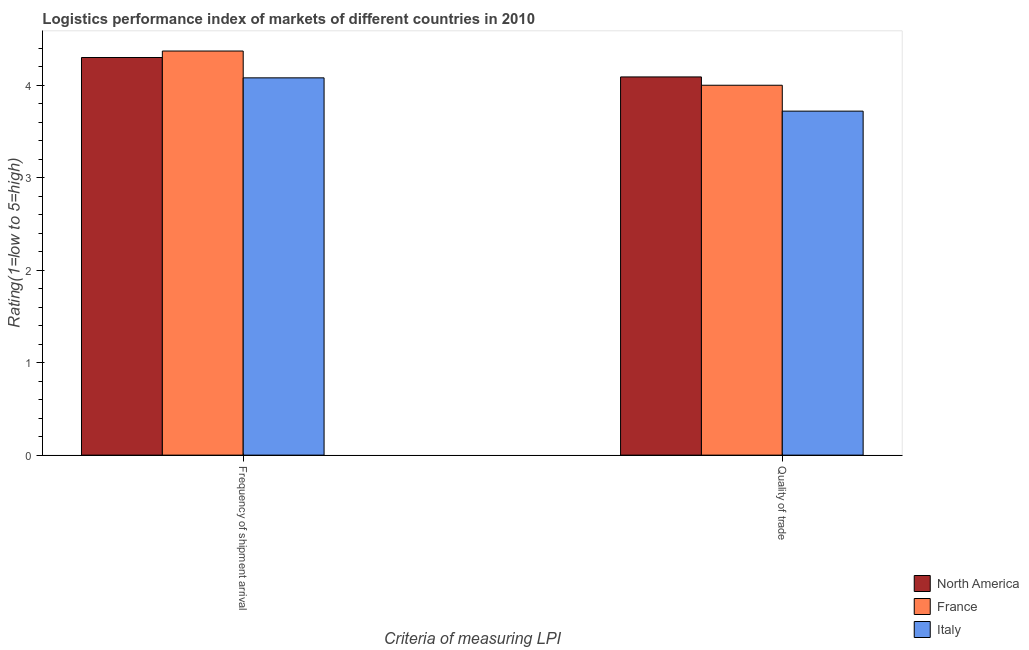How many groups of bars are there?
Provide a succinct answer. 2. Are the number of bars per tick equal to the number of legend labels?
Your response must be concise. Yes. Are the number of bars on each tick of the X-axis equal?
Provide a short and direct response. Yes. How many bars are there on the 1st tick from the right?
Provide a short and direct response. 3. What is the label of the 2nd group of bars from the left?
Your response must be concise. Quality of trade. What is the lpi quality of trade in North America?
Make the answer very short. 4.09. Across all countries, what is the maximum lpi of frequency of shipment arrival?
Your answer should be very brief. 4.37. Across all countries, what is the minimum lpi quality of trade?
Your response must be concise. 3.72. What is the total lpi of frequency of shipment arrival in the graph?
Ensure brevity in your answer.  12.75. What is the difference between the lpi of frequency of shipment arrival in North America and that in Italy?
Ensure brevity in your answer.  0.22. What is the difference between the lpi quality of trade in France and the lpi of frequency of shipment arrival in North America?
Your answer should be very brief. -0.3. What is the average lpi quality of trade per country?
Give a very brief answer. 3.94. What is the difference between the lpi quality of trade and lpi of frequency of shipment arrival in Italy?
Provide a succinct answer. -0.36. In how many countries, is the lpi of frequency of shipment arrival greater than 1.6 ?
Offer a very short reply. 3. What is the ratio of the lpi of frequency of shipment arrival in North America to that in France?
Provide a short and direct response. 0.98. Is the lpi quality of trade in France less than that in Italy?
Offer a very short reply. No. In how many countries, is the lpi of frequency of shipment arrival greater than the average lpi of frequency of shipment arrival taken over all countries?
Ensure brevity in your answer.  2. What does the 3rd bar from the left in Quality of trade represents?
Provide a short and direct response. Italy. What does the 3rd bar from the right in Quality of trade represents?
Keep it short and to the point. North America. How many countries are there in the graph?
Your answer should be compact. 3. Are the values on the major ticks of Y-axis written in scientific E-notation?
Make the answer very short. No. Does the graph contain any zero values?
Provide a succinct answer. No. How are the legend labels stacked?
Ensure brevity in your answer.  Vertical. What is the title of the graph?
Make the answer very short. Logistics performance index of markets of different countries in 2010. Does "Liberia" appear as one of the legend labels in the graph?
Offer a terse response. No. What is the label or title of the X-axis?
Offer a very short reply. Criteria of measuring LPI. What is the label or title of the Y-axis?
Keep it short and to the point. Rating(1=low to 5=high). What is the Rating(1=low to 5=high) in France in Frequency of shipment arrival?
Offer a very short reply. 4.37. What is the Rating(1=low to 5=high) in Italy in Frequency of shipment arrival?
Provide a succinct answer. 4.08. What is the Rating(1=low to 5=high) in North America in Quality of trade?
Provide a short and direct response. 4.09. What is the Rating(1=low to 5=high) in Italy in Quality of trade?
Your answer should be very brief. 3.72. Across all Criteria of measuring LPI, what is the maximum Rating(1=low to 5=high) of France?
Your response must be concise. 4.37. Across all Criteria of measuring LPI, what is the maximum Rating(1=low to 5=high) in Italy?
Make the answer very short. 4.08. Across all Criteria of measuring LPI, what is the minimum Rating(1=low to 5=high) of North America?
Offer a very short reply. 4.09. Across all Criteria of measuring LPI, what is the minimum Rating(1=low to 5=high) in Italy?
Provide a succinct answer. 3.72. What is the total Rating(1=low to 5=high) of North America in the graph?
Provide a succinct answer. 8.39. What is the total Rating(1=low to 5=high) in France in the graph?
Your answer should be very brief. 8.37. What is the difference between the Rating(1=low to 5=high) of North America in Frequency of shipment arrival and that in Quality of trade?
Offer a terse response. 0.21. What is the difference between the Rating(1=low to 5=high) in France in Frequency of shipment arrival and that in Quality of trade?
Provide a short and direct response. 0.37. What is the difference between the Rating(1=low to 5=high) in Italy in Frequency of shipment arrival and that in Quality of trade?
Offer a very short reply. 0.36. What is the difference between the Rating(1=low to 5=high) in North America in Frequency of shipment arrival and the Rating(1=low to 5=high) in France in Quality of trade?
Your answer should be very brief. 0.3. What is the difference between the Rating(1=low to 5=high) of North America in Frequency of shipment arrival and the Rating(1=low to 5=high) of Italy in Quality of trade?
Provide a short and direct response. 0.58. What is the difference between the Rating(1=low to 5=high) of France in Frequency of shipment arrival and the Rating(1=low to 5=high) of Italy in Quality of trade?
Make the answer very short. 0.65. What is the average Rating(1=low to 5=high) in North America per Criteria of measuring LPI?
Offer a terse response. 4.2. What is the average Rating(1=low to 5=high) in France per Criteria of measuring LPI?
Offer a very short reply. 4.18. What is the average Rating(1=low to 5=high) in Italy per Criteria of measuring LPI?
Keep it short and to the point. 3.9. What is the difference between the Rating(1=low to 5=high) of North America and Rating(1=low to 5=high) of France in Frequency of shipment arrival?
Provide a succinct answer. -0.07. What is the difference between the Rating(1=low to 5=high) of North America and Rating(1=low to 5=high) of Italy in Frequency of shipment arrival?
Ensure brevity in your answer.  0.22. What is the difference between the Rating(1=low to 5=high) in France and Rating(1=low to 5=high) in Italy in Frequency of shipment arrival?
Offer a terse response. 0.29. What is the difference between the Rating(1=low to 5=high) in North America and Rating(1=low to 5=high) in France in Quality of trade?
Provide a succinct answer. 0.09. What is the difference between the Rating(1=low to 5=high) in North America and Rating(1=low to 5=high) in Italy in Quality of trade?
Offer a terse response. 0.37. What is the difference between the Rating(1=low to 5=high) of France and Rating(1=low to 5=high) of Italy in Quality of trade?
Your answer should be very brief. 0.28. What is the ratio of the Rating(1=low to 5=high) in North America in Frequency of shipment arrival to that in Quality of trade?
Ensure brevity in your answer.  1.05. What is the ratio of the Rating(1=low to 5=high) of France in Frequency of shipment arrival to that in Quality of trade?
Provide a short and direct response. 1.09. What is the ratio of the Rating(1=low to 5=high) of Italy in Frequency of shipment arrival to that in Quality of trade?
Your response must be concise. 1.1. What is the difference between the highest and the second highest Rating(1=low to 5=high) in North America?
Ensure brevity in your answer.  0.21. What is the difference between the highest and the second highest Rating(1=low to 5=high) in France?
Give a very brief answer. 0.37. What is the difference between the highest and the second highest Rating(1=low to 5=high) of Italy?
Ensure brevity in your answer.  0.36. What is the difference between the highest and the lowest Rating(1=low to 5=high) of North America?
Provide a short and direct response. 0.21. What is the difference between the highest and the lowest Rating(1=low to 5=high) of France?
Your response must be concise. 0.37. What is the difference between the highest and the lowest Rating(1=low to 5=high) in Italy?
Give a very brief answer. 0.36. 